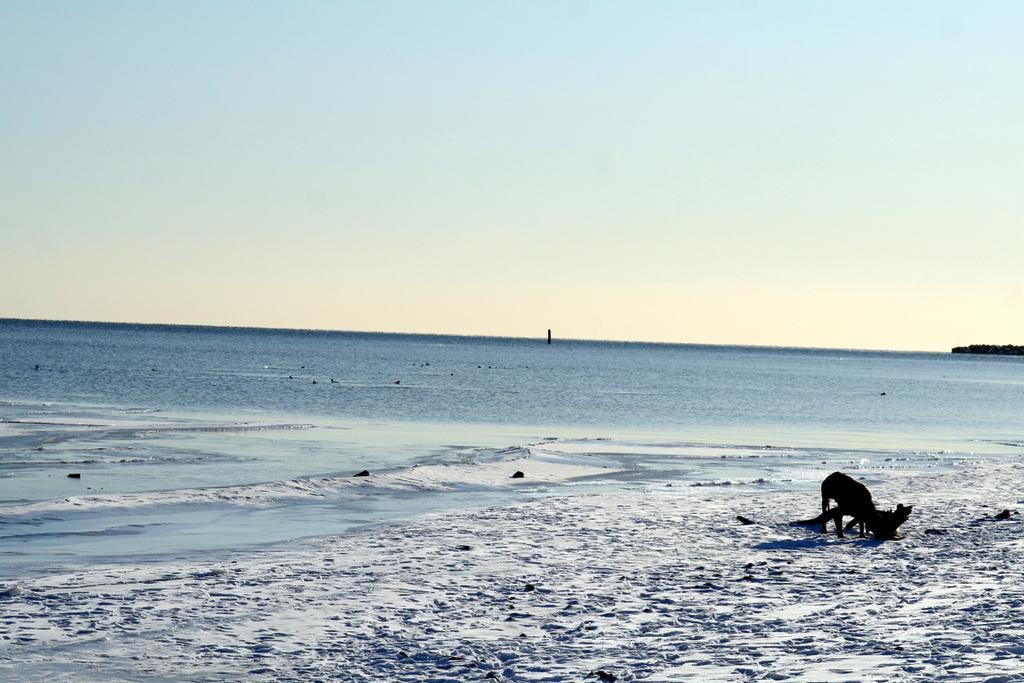In one or two sentences, can you explain what this image depicts? This is the picture of a sea. On the right side of the image there is an animal standing. At the back there are trees. At the top there is sky. At the bottom there is water and sand. 